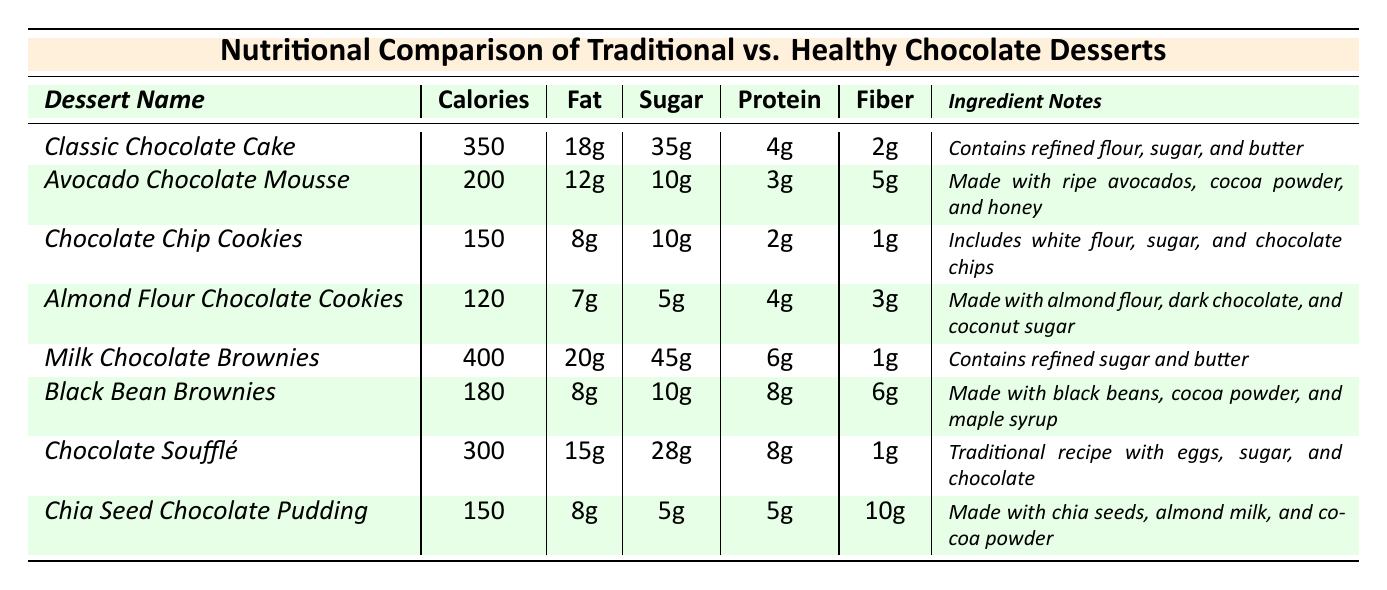What is the calorie count of the Almond Flour Chocolate Cookies? The table provides the calorie count for each dessert. The Almond Flour Chocolate Cookies are listed with a calorie count of 120.
Answer: 120 Which dessert has the highest fat content? By checking the fat content of each dessert in the table, Milk Chocolate Brownies have the highest fat content at 20g.
Answer: 20g What is the total sugar content of the two chocolate desserts with the lowest sugar? The two desserts with the lowest sugar are Almond Flour Chocolate Cookies with 5g and Chia Seed Chocolate Pudding with 5g. Summing these gives 5g + 5g = 10g.
Answer: 10g Is the protein content in Black Bean Brownies higher than in Classic Chocolate Cake? The protein content for Black Bean Brownies is 8g, while for Classic Chocolate Cake it is 4g. Since 8g is greater than 4g, the statement is true.
Answer: Yes What is the average calorie count of the healthy chocolate desserts listed? The healthy desserts are Avocado Chocolate Mousse (200), Almond Flour Chocolate Cookies (120), Black Bean Brownies (180), and Chia Seed Chocolate Pudding (150). The sum is 200 + 120 + 180 + 150 = 650. There are 4 desserts, so the average is 650 / 4 = 162.5.
Answer: 162.5 How many desserts contain refined sugar? The desserts containing refined sugar are Classic Chocolate Cake, Milk Chocolate Brownies, and Chocolate Chip Cookies. There are 3 desserts in total.
Answer: 3 Which dessert has the highest fiber content? By examining the fiber content in the table, Chia Seed Chocolate Pudding has the highest fiber content at 10g.
Answer: 10g What is the total calorie difference between the highest and lowest calorie desserts? The highest calorie dessert is Milk Chocolate Brownies at 400 calories, and the lowest is Almond Flour Chocolate Cookies at 120 calories. The difference is 400 - 120 = 280.
Answer: 280 Is it true that all healthy desserts have less than 200 calories? The healthy desserts are Avocado Chocolate Mousse (200), Almond Flour Chocolate Cookies (120), Black Bean Brownies (180), and Chia Seed Chocolate Pudding (150). Since Avocado Chocolate Mousse has 200 calories, not all are below 200.
Answer: No What dessert provides the most protein compared to its calorie content? By calculating the protein per calorie for each dessert, Black Bean Brownies have 8g protein for 180 calories, yielding 0.044g/calorie, which is higher than others.
Answer: Black Bean Brownies 